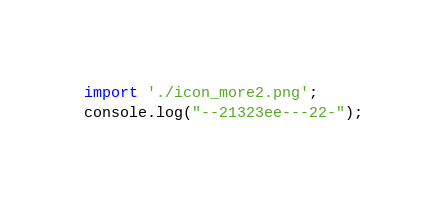Convert code to text. <code><loc_0><loc_0><loc_500><loc_500><_JavaScript_>import './icon_more2.png';
console.log("--21323ee---22-");</code> 